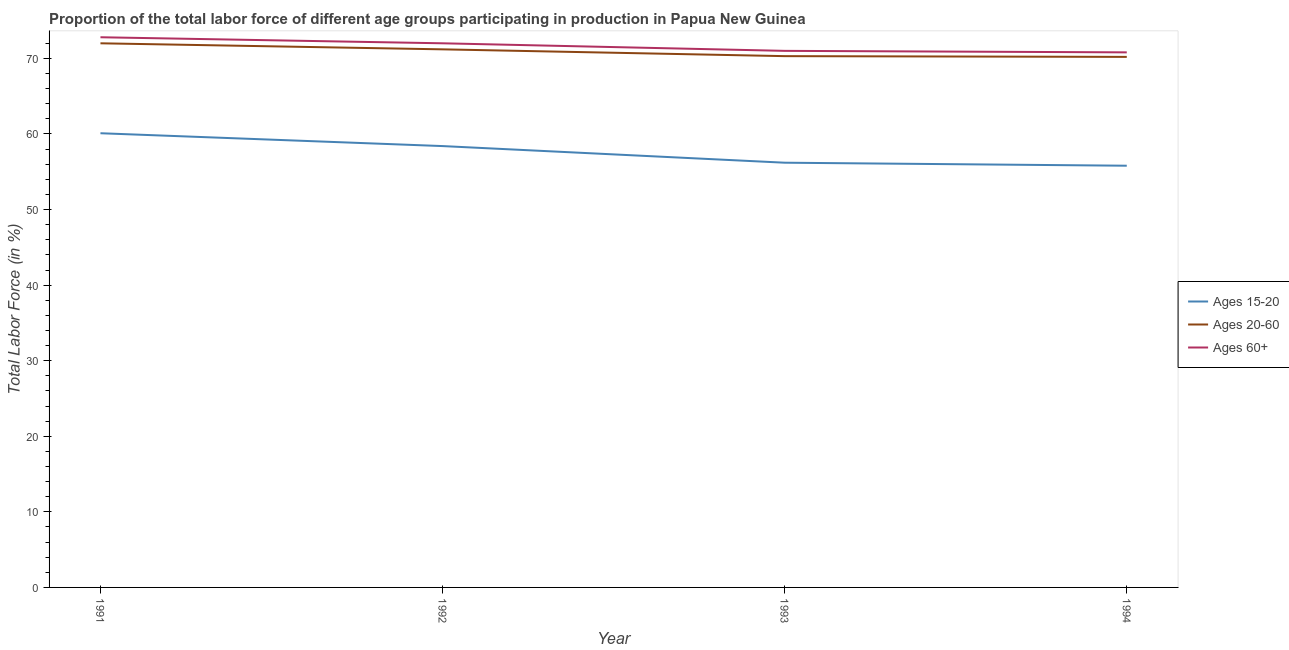Across all years, what is the minimum percentage of labor force above age 60?
Offer a very short reply. 70.8. In which year was the percentage of labor force within the age group 20-60 minimum?
Give a very brief answer. 1994. What is the total percentage of labor force above age 60 in the graph?
Make the answer very short. 286.6. What is the difference between the percentage of labor force within the age group 15-20 in 1991 and that in 1992?
Your response must be concise. 1.7. What is the difference between the percentage of labor force within the age group 15-20 in 1994 and the percentage of labor force within the age group 20-60 in 1993?
Your answer should be very brief. -14.5. What is the average percentage of labor force within the age group 20-60 per year?
Ensure brevity in your answer.  70.92. In the year 1991, what is the difference between the percentage of labor force within the age group 20-60 and percentage of labor force within the age group 15-20?
Provide a short and direct response. 11.9. What is the ratio of the percentage of labor force within the age group 20-60 in 1991 to that in 1993?
Make the answer very short. 1.02. What is the difference between the highest and the second highest percentage of labor force above age 60?
Keep it short and to the point. 0.8. What is the difference between the highest and the lowest percentage of labor force above age 60?
Offer a very short reply. 2. Is the percentage of labor force within the age group 15-20 strictly greater than the percentage of labor force within the age group 20-60 over the years?
Keep it short and to the point. No. How many years are there in the graph?
Keep it short and to the point. 4. What is the difference between two consecutive major ticks on the Y-axis?
Ensure brevity in your answer.  10. Are the values on the major ticks of Y-axis written in scientific E-notation?
Make the answer very short. No. Does the graph contain any zero values?
Keep it short and to the point. No. How are the legend labels stacked?
Provide a short and direct response. Vertical. What is the title of the graph?
Offer a terse response. Proportion of the total labor force of different age groups participating in production in Papua New Guinea. Does "Negligence towards kids" appear as one of the legend labels in the graph?
Offer a very short reply. No. What is the Total Labor Force (in %) in Ages 15-20 in 1991?
Ensure brevity in your answer.  60.1. What is the Total Labor Force (in %) of Ages 20-60 in 1991?
Your answer should be compact. 72. What is the Total Labor Force (in %) of Ages 60+ in 1991?
Provide a short and direct response. 72.8. What is the Total Labor Force (in %) in Ages 15-20 in 1992?
Provide a succinct answer. 58.4. What is the Total Labor Force (in %) of Ages 20-60 in 1992?
Your answer should be very brief. 71.2. What is the Total Labor Force (in %) in Ages 15-20 in 1993?
Make the answer very short. 56.2. What is the Total Labor Force (in %) in Ages 20-60 in 1993?
Give a very brief answer. 70.3. What is the Total Labor Force (in %) in Ages 60+ in 1993?
Your answer should be very brief. 71. What is the Total Labor Force (in %) of Ages 15-20 in 1994?
Your answer should be very brief. 55.8. What is the Total Labor Force (in %) in Ages 20-60 in 1994?
Your answer should be compact. 70.2. What is the Total Labor Force (in %) in Ages 60+ in 1994?
Offer a very short reply. 70.8. Across all years, what is the maximum Total Labor Force (in %) in Ages 15-20?
Your response must be concise. 60.1. Across all years, what is the maximum Total Labor Force (in %) in Ages 60+?
Your answer should be compact. 72.8. Across all years, what is the minimum Total Labor Force (in %) of Ages 15-20?
Your answer should be very brief. 55.8. Across all years, what is the minimum Total Labor Force (in %) in Ages 20-60?
Offer a terse response. 70.2. Across all years, what is the minimum Total Labor Force (in %) of Ages 60+?
Your answer should be very brief. 70.8. What is the total Total Labor Force (in %) of Ages 15-20 in the graph?
Your answer should be compact. 230.5. What is the total Total Labor Force (in %) in Ages 20-60 in the graph?
Keep it short and to the point. 283.7. What is the total Total Labor Force (in %) of Ages 60+ in the graph?
Make the answer very short. 286.6. What is the difference between the Total Labor Force (in %) in Ages 15-20 in 1991 and that in 1992?
Provide a succinct answer. 1.7. What is the difference between the Total Labor Force (in %) of Ages 20-60 in 1991 and that in 1992?
Provide a short and direct response. 0.8. What is the difference between the Total Labor Force (in %) in Ages 60+ in 1991 and that in 1992?
Ensure brevity in your answer.  0.8. What is the difference between the Total Labor Force (in %) in Ages 15-20 in 1991 and that in 1993?
Offer a very short reply. 3.9. What is the difference between the Total Labor Force (in %) in Ages 60+ in 1991 and that in 1993?
Your answer should be very brief. 1.8. What is the difference between the Total Labor Force (in %) in Ages 20-60 in 1991 and that in 1994?
Offer a very short reply. 1.8. What is the difference between the Total Labor Force (in %) in Ages 20-60 in 1992 and that in 1993?
Provide a short and direct response. 0.9. What is the difference between the Total Labor Force (in %) of Ages 15-20 in 1992 and that in 1994?
Your answer should be compact. 2.6. What is the difference between the Total Labor Force (in %) of Ages 15-20 in 1993 and that in 1994?
Provide a succinct answer. 0.4. What is the difference between the Total Labor Force (in %) of Ages 15-20 in 1991 and the Total Labor Force (in %) of Ages 20-60 in 1992?
Ensure brevity in your answer.  -11.1. What is the difference between the Total Labor Force (in %) of Ages 15-20 in 1991 and the Total Labor Force (in %) of Ages 60+ in 1992?
Offer a terse response. -11.9. What is the difference between the Total Labor Force (in %) in Ages 20-60 in 1991 and the Total Labor Force (in %) in Ages 60+ in 1992?
Provide a succinct answer. 0. What is the difference between the Total Labor Force (in %) in Ages 15-20 in 1991 and the Total Labor Force (in %) in Ages 60+ in 1993?
Your answer should be very brief. -10.9. What is the difference between the Total Labor Force (in %) of Ages 15-20 in 1992 and the Total Labor Force (in %) of Ages 60+ in 1993?
Make the answer very short. -12.6. What is the difference between the Total Labor Force (in %) of Ages 20-60 in 1992 and the Total Labor Force (in %) of Ages 60+ in 1993?
Provide a short and direct response. 0.2. What is the difference between the Total Labor Force (in %) in Ages 15-20 in 1992 and the Total Labor Force (in %) in Ages 60+ in 1994?
Offer a very short reply. -12.4. What is the difference between the Total Labor Force (in %) of Ages 15-20 in 1993 and the Total Labor Force (in %) of Ages 60+ in 1994?
Give a very brief answer. -14.6. What is the difference between the Total Labor Force (in %) of Ages 20-60 in 1993 and the Total Labor Force (in %) of Ages 60+ in 1994?
Ensure brevity in your answer.  -0.5. What is the average Total Labor Force (in %) of Ages 15-20 per year?
Ensure brevity in your answer.  57.62. What is the average Total Labor Force (in %) of Ages 20-60 per year?
Ensure brevity in your answer.  70.92. What is the average Total Labor Force (in %) in Ages 60+ per year?
Offer a terse response. 71.65. In the year 1991, what is the difference between the Total Labor Force (in %) of Ages 15-20 and Total Labor Force (in %) of Ages 20-60?
Provide a succinct answer. -11.9. In the year 1991, what is the difference between the Total Labor Force (in %) of Ages 15-20 and Total Labor Force (in %) of Ages 60+?
Offer a terse response. -12.7. In the year 1991, what is the difference between the Total Labor Force (in %) of Ages 20-60 and Total Labor Force (in %) of Ages 60+?
Your answer should be compact. -0.8. In the year 1993, what is the difference between the Total Labor Force (in %) in Ages 15-20 and Total Labor Force (in %) in Ages 20-60?
Provide a succinct answer. -14.1. In the year 1993, what is the difference between the Total Labor Force (in %) of Ages 15-20 and Total Labor Force (in %) of Ages 60+?
Keep it short and to the point. -14.8. In the year 1994, what is the difference between the Total Labor Force (in %) of Ages 15-20 and Total Labor Force (in %) of Ages 20-60?
Your answer should be very brief. -14.4. What is the ratio of the Total Labor Force (in %) of Ages 15-20 in 1991 to that in 1992?
Provide a short and direct response. 1.03. What is the ratio of the Total Labor Force (in %) in Ages 20-60 in 1991 to that in 1992?
Provide a succinct answer. 1.01. What is the ratio of the Total Labor Force (in %) in Ages 60+ in 1991 to that in 1992?
Provide a succinct answer. 1.01. What is the ratio of the Total Labor Force (in %) in Ages 15-20 in 1991 to that in 1993?
Your answer should be compact. 1.07. What is the ratio of the Total Labor Force (in %) in Ages 20-60 in 1991 to that in 1993?
Your response must be concise. 1.02. What is the ratio of the Total Labor Force (in %) of Ages 60+ in 1991 to that in 1993?
Offer a terse response. 1.03. What is the ratio of the Total Labor Force (in %) of Ages 15-20 in 1991 to that in 1994?
Your answer should be very brief. 1.08. What is the ratio of the Total Labor Force (in %) of Ages 20-60 in 1991 to that in 1994?
Your answer should be compact. 1.03. What is the ratio of the Total Labor Force (in %) in Ages 60+ in 1991 to that in 1994?
Your response must be concise. 1.03. What is the ratio of the Total Labor Force (in %) of Ages 15-20 in 1992 to that in 1993?
Your response must be concise. 1.04. What is the ratio of the Total Labor Force (in %) in Ages 20-60 in 1992 to that in 1993?
Offer a terse response. 1.01. What is the ratio of the Total Labor Force (in %) in Ages 60+ in 1992 to that in 1993?
Make the answer very short. 1.01. What is the ratio of the Total Labor Force (in %) of Ages 15-20 in 1992 to that in 1994?
Give a very brief answer. 1.05. What is the ratio of the Total Labor Force (in %) in Ages 20-60 in 1992 to that in 1994?
Provide a short and direct response. 1.01. What is the ratio of the Total Labor Force (in %) of Ages 60+ in 1992 to that in 1994?
Offer a terse response. 1.02. What is the difference between the highest and the second highest Total Labor Force (in %) of Ages 15-20?
Provide a succinct answer. 1.7. What is the difference between the highest and the second highest Total Labor Force (in %) in Ages 60+?
Offer a terse response. 0.8. 